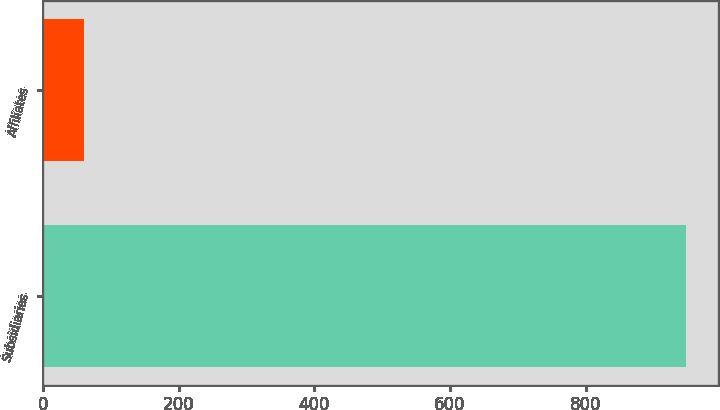Convert chart to OTSL. <chart><loc_0><loc_0><loc_500><loc_500><bar_chart><fcel>Subsidiaries<fcel>Affiliates<nl><fcel>948<fcel>60<nl></chart> 